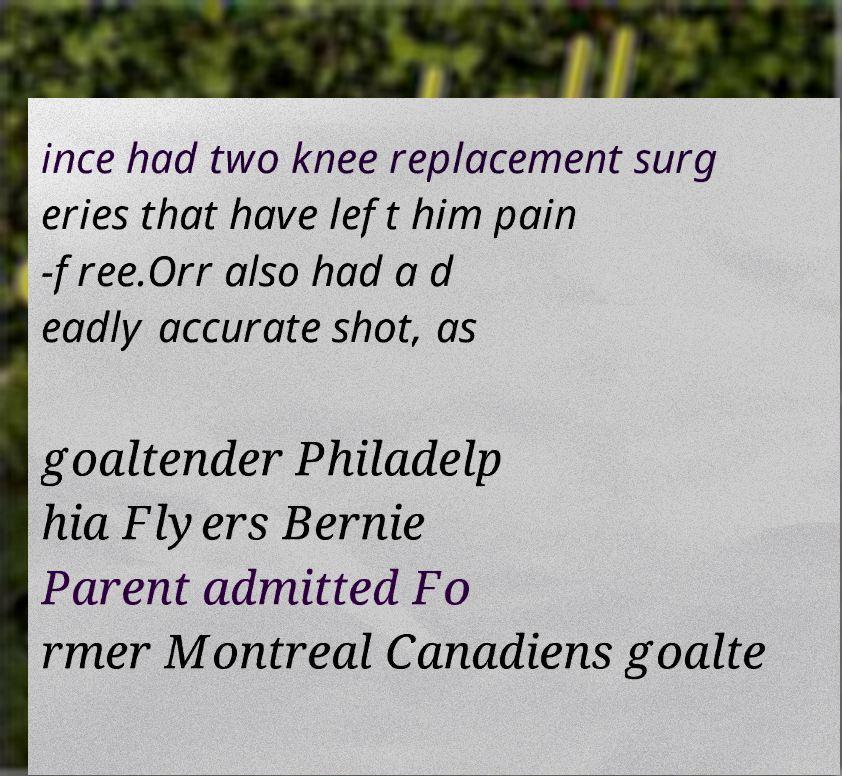Could you extract and type out the text from this image? ince had two knee replacement surg eries that have left him pain -free.Orr also had a d eadly accurate shot, as goaltender Philadelp hia Flyers Bernie Parent admitted Fo rmer Montreal Canadiens goalte 